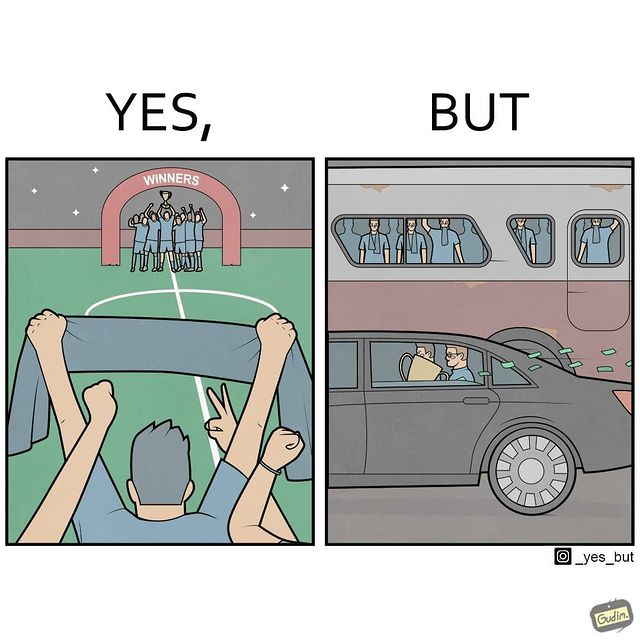What do you see in each half of this image? In the left part of the image: A football team has won some tournament, where the team with the cup are celebrating, along with their fans in the gallery. In the right part of the image: some people are standing in a bus, while some other people are travelling in a car carrying a cup, while cash notes are flowing out the car window. 